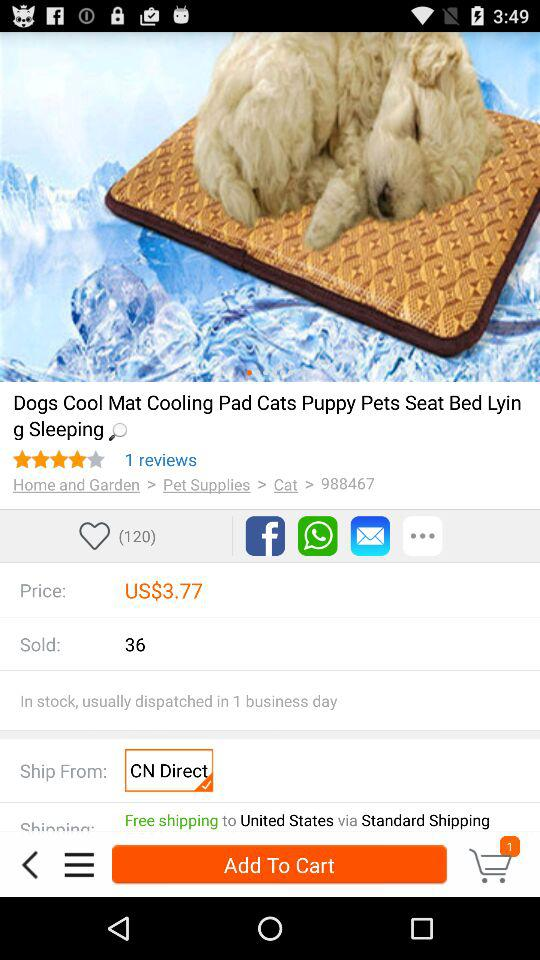What applications are used to share? The applications are: "Facebook", "WhatsApp", and "Message". 